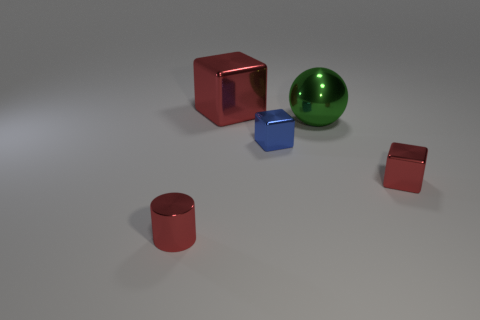There is a small cube to the left of the large object in front of the large red cube; what color is it?
Give a very brief answer. Blue. There is a metal cube that is the same size as the blue metallic object; what is its color?
Your answer should be very brief. Red. Is there a cyan rubber object of the same shape as the green thing?
Provide a succinct answer. No. The big red metal thing has what shape?
Provide a short and direct response. Cube. Is the number of large things to the left of the small blue block greater than the number of tiny red metal things left of the large metal ball?
Give a very brief answer. No. How many other objects are the same size as the red cylinder?
Make the answer very short. 2. What is the material of the object that is left of the small blue metal block and to the right of the red metallic cylinder?
Your answer should be very brief. Metal. What material is the other red thing that is the same shape as the big red thing?
Offer a terse response. Metal. There is a big green shiny object left of the tiny red thing on the right side of the red cylinder; what number of big red shiny blocks are left of it?
Offer a terse response. 1. Is there any other thing that has the same color as the sphere?
Provide a short and direct response. No. 